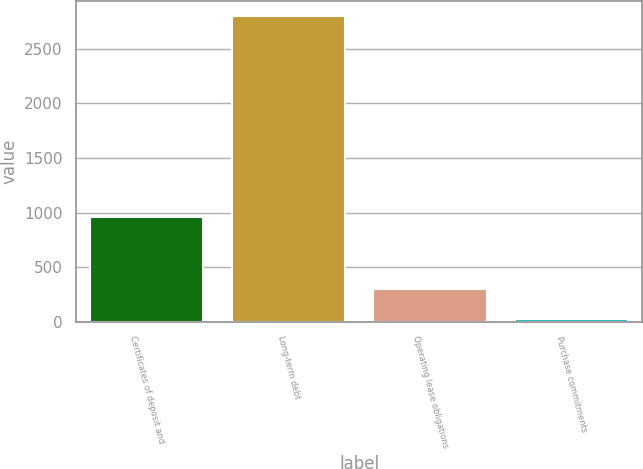Convert chart to OTSL. <chart><loc_0><loc_0><loc_500><loc_500><bar_chart><fcel>Certificates of deposit and<fcel>Long-term debt<fcel>Operating lease obligations<fcel>Purchase commitments<nl><fcel>962<fcel>2798<fcel>302.3<fcel>25<nl></chart> 